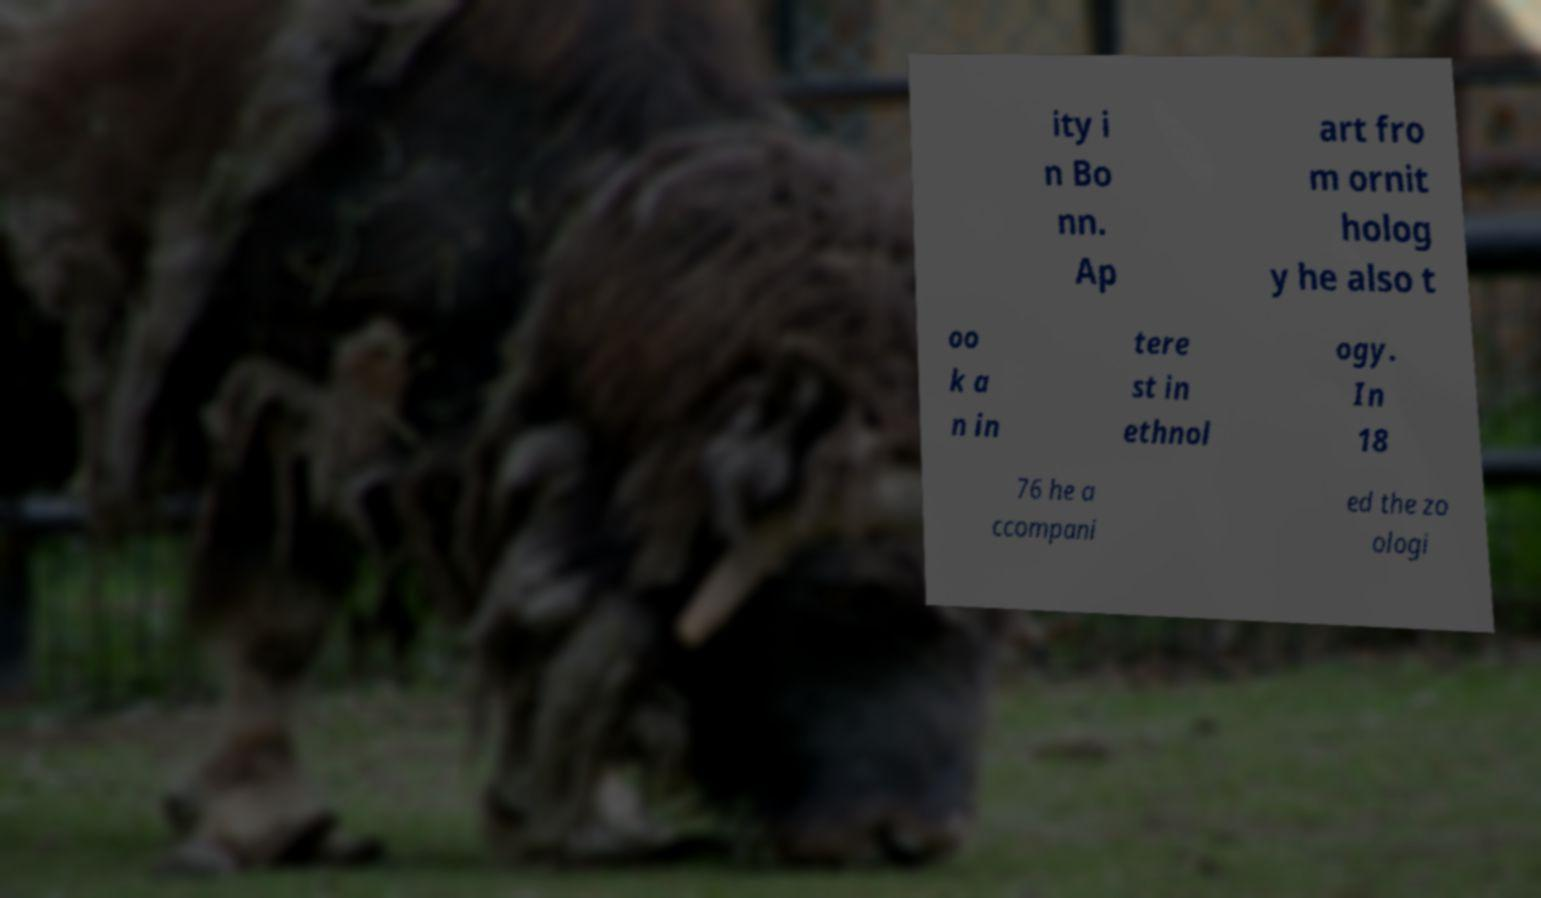For documentation purposes, I need the text within this image transcribed. Could you provide that? ity i n Bo nn. Ap art fro m ornit holog y he also t oo k a n in tere st in ethnol ogy. In 18 76 he a ccompani ed the zo ologi 